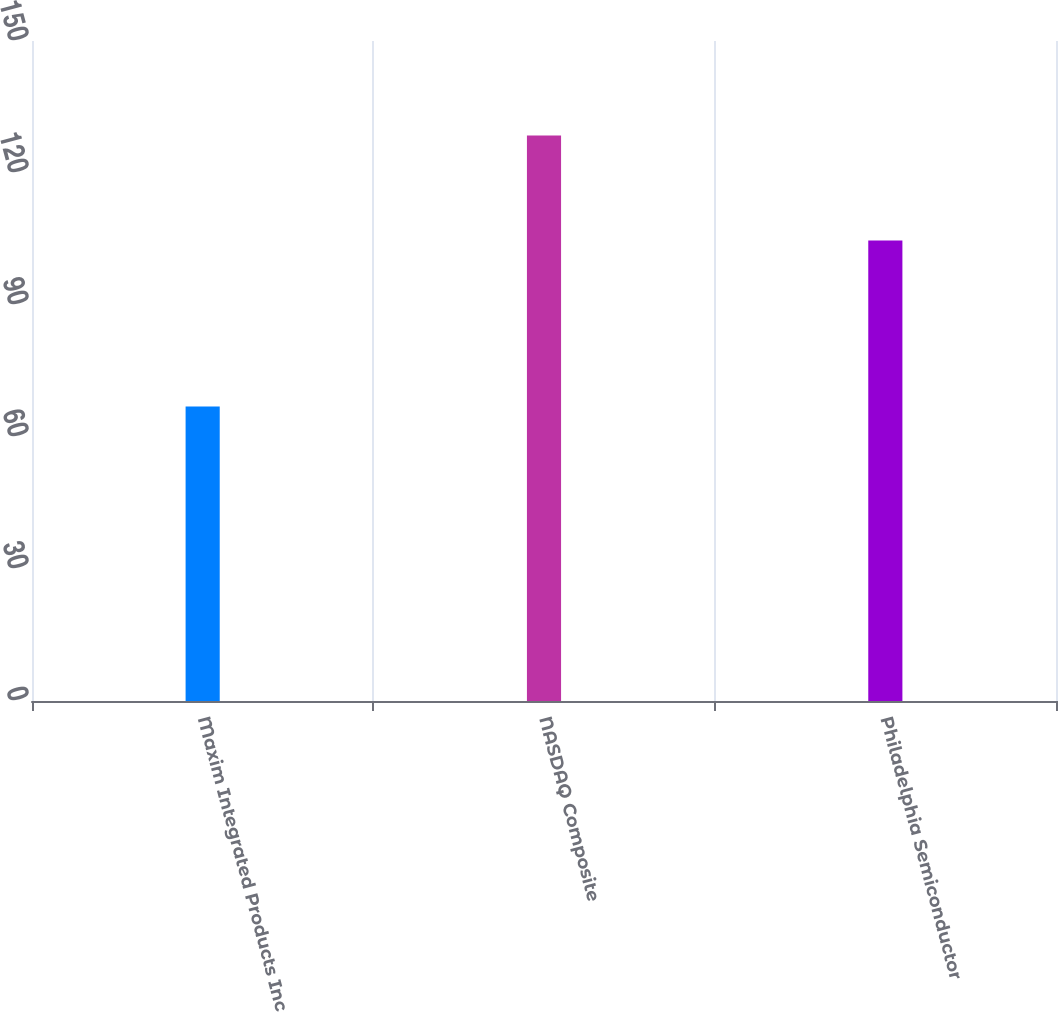Convert chart to OTSL. <chart><loc_0><loc_0><loc_500><loc_500><bar_chart><fcel>Maxim Integrated Products Inc<fcel>NASDAQ Composite<fcel>Philadelphia Semiconductor<nl><fcel>66.96<fcel>128.52<fcel>104.65<nl></chart> 